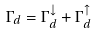<formula> <loc_0><loc_0><loc_500><loc_500>\Gamma _ { d } = \Gamma _ { d } ^ { \downarrow } + \Gamma _ { d } ^ { \uparrow }</formula> 